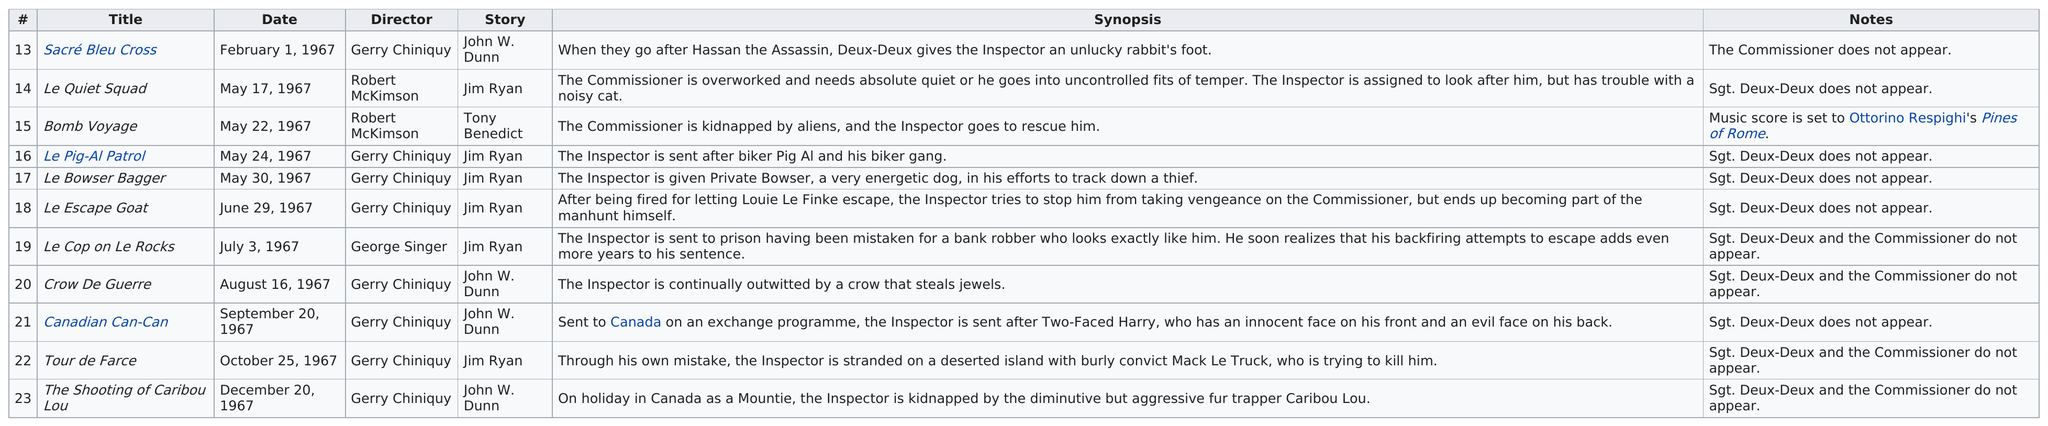List a handful of essential elements in this visual. The latest book release date is December 20, 1967. After the cartoon "Le Quiet Squad," directed by Robert McKimson, the next cartoon directed by him was "Bomb Voyage. The 1967 episode of The Inspector titled "Bomb Voyage" is the only one written by Tony Benedict. The number of stories directed by Jim Ryan is six. In 1967, George Singer directed the least number of episodes of "The Inspector. 